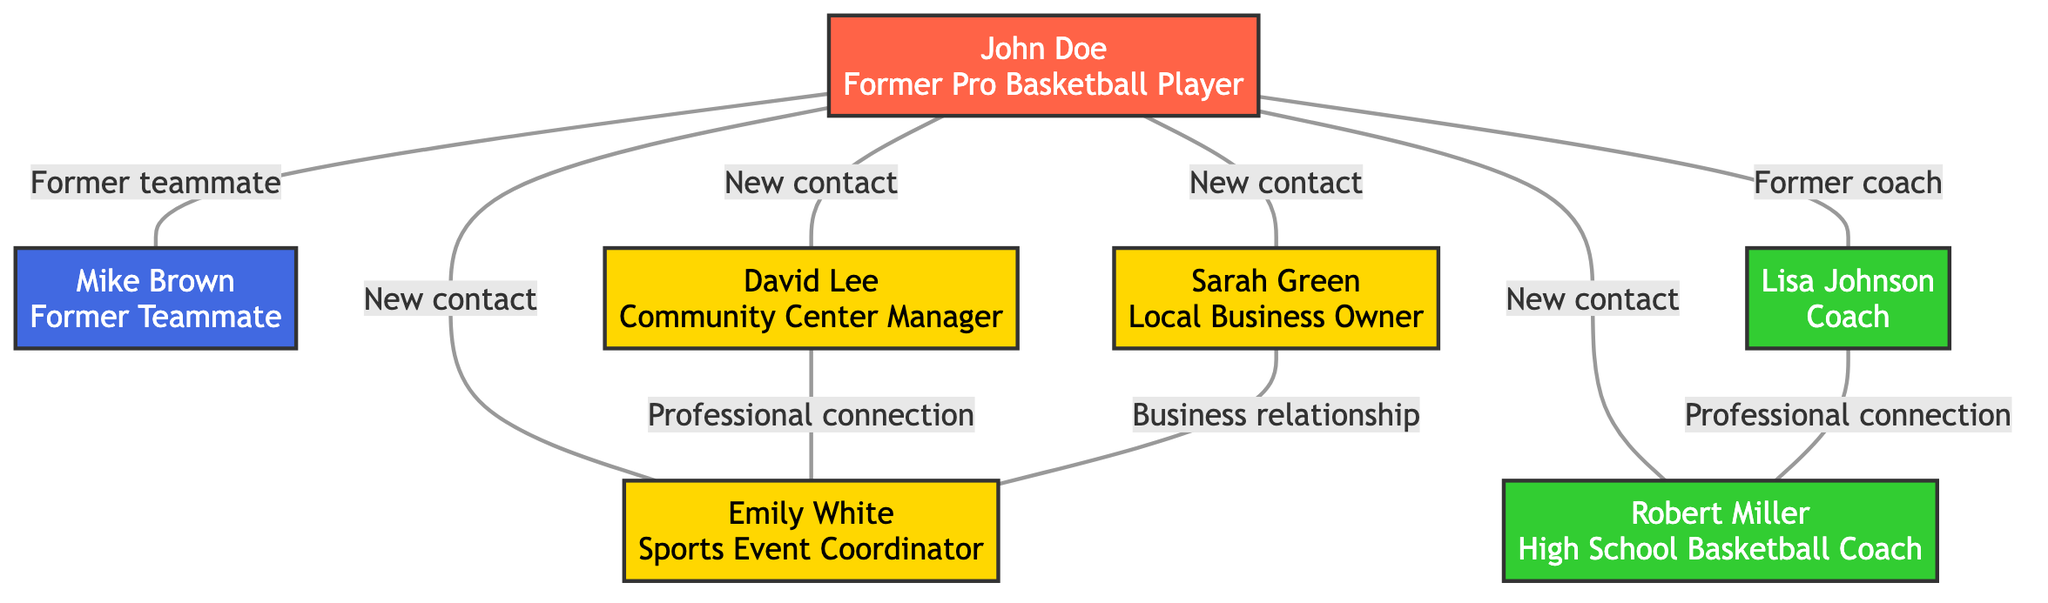What is John Doe's role? The diagram labels John Doe as "Former Pro Basketball Player" under the node identifier, indicating his profession and status.
Answer: Former Pro Basketball Player How many new contacts does John Doe have? By reviewing the links connected to John Doe, there are three relationships identified as "New contact," which correspond to Sarah Green, David Lee, and Emily White.
Answer: 3 Who is Lisa Johnson connected to? Lisa Johnson (the Coach) is connected to Robert Miller (High School Basketball Coach) through a relationship labeled "Professional connection."
Answer: Robert Miller What type of relationship does John Doe have with Mike Brown? Referring to the link between John Doe and Mike Brown, it is explicitly marked as "Former teammate," indicating their past collaboration on the basketball team.
Answer: Former teammate How many nodes are in the diagram? The total number of nodes can be calculated by counting each entry in the nodes list, revealing seven distinct individuals represented in the diagram.
Answer: 7 Which contact has a business relationship with Emily White? Analyzing the links, it reveals that Sarah Green has a "Business relationship" with Emily White, establishing a working connection between these two individuals.
Answer: Sarah Green What is the relationship between David Lee and Emily White? The link between David Lee and Emily White is identified as a "Professional connection," indicating they share a formal relationship in their respective fields.
Answer: Professional connection How many coaches are represented in the diagram? By inspecting the nodes, it becomes clear that there are two designated coaches, Lisa Johnson and Robert Miller, present in the diagram.
Answer: 2 What is the primary function of Robert Miller in this community network? Robert Miller is recognized as a "High School Basketball Coach," emphasizing his role within the educational and athletic framework of the community.
Answer: High School Basketball Coach 